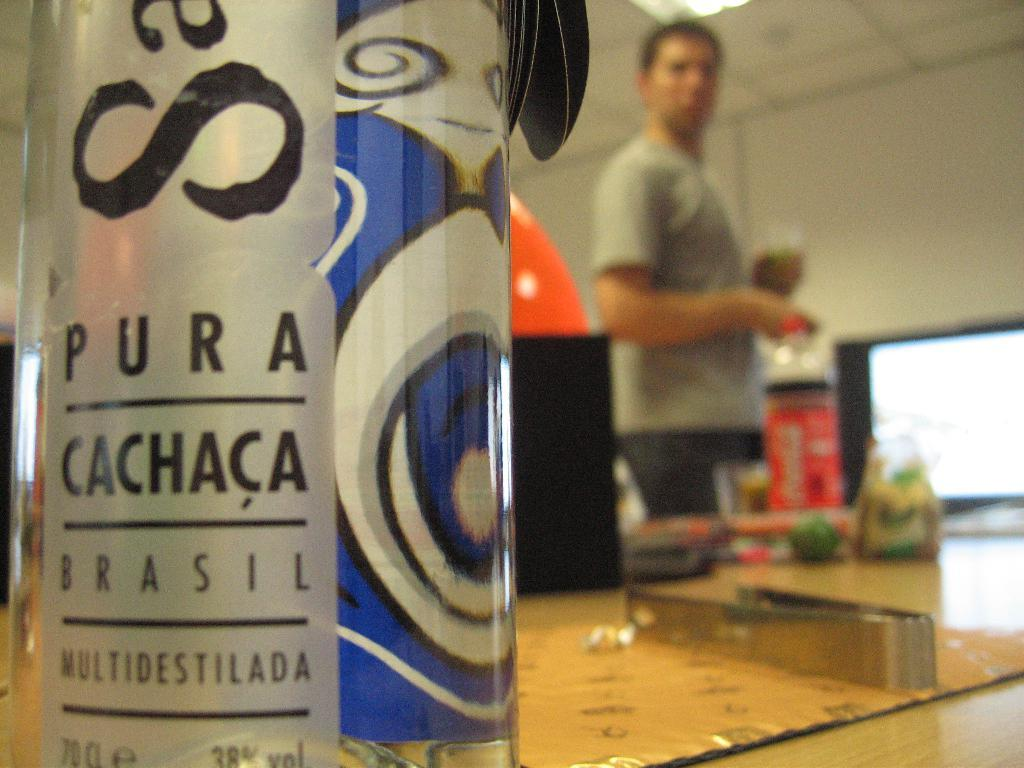<image>
Give a short and clear explanation of the subsequent image. A man is standing in the background of PURA CACHACA BRASIL. 